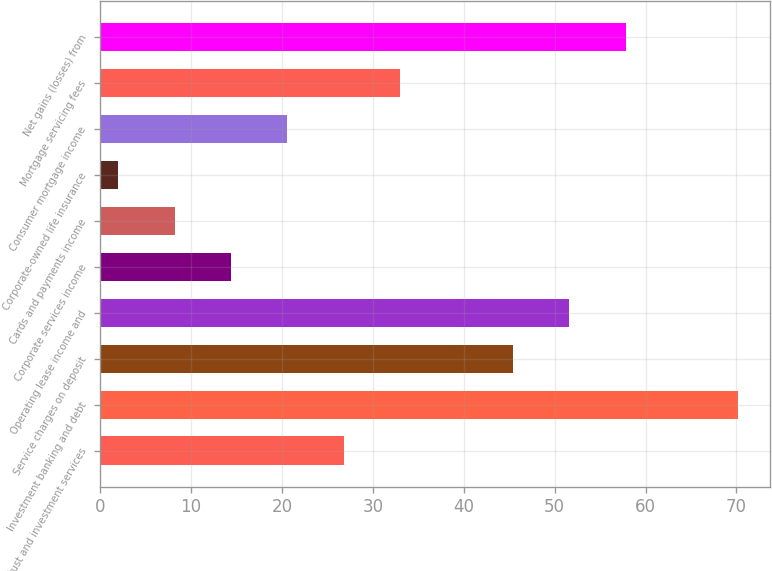<chart> <loc_0><loc_0><loc_500><loc_500><bar_chart><fcel>Trust and investment services<fcel>Investment banking and debt<fcel>Service charges on deposit<fcel>Operating lease income and<fcel>Corporate services income<fcel>Cards and payments income<fcel>Corporate-owned life insurance<fcel>Consumer mortgage income<fcel>Mortgage servicing fees<fcel>Net gains (losses) from<nl><fcel>26.8<fcel>70.2<fcel>45.4<fcel>51.6<fcel>14.4<fcel>8.2<fcel>2<fcel>20.6<fcel>33<fcel>57.8<nl></chart> 